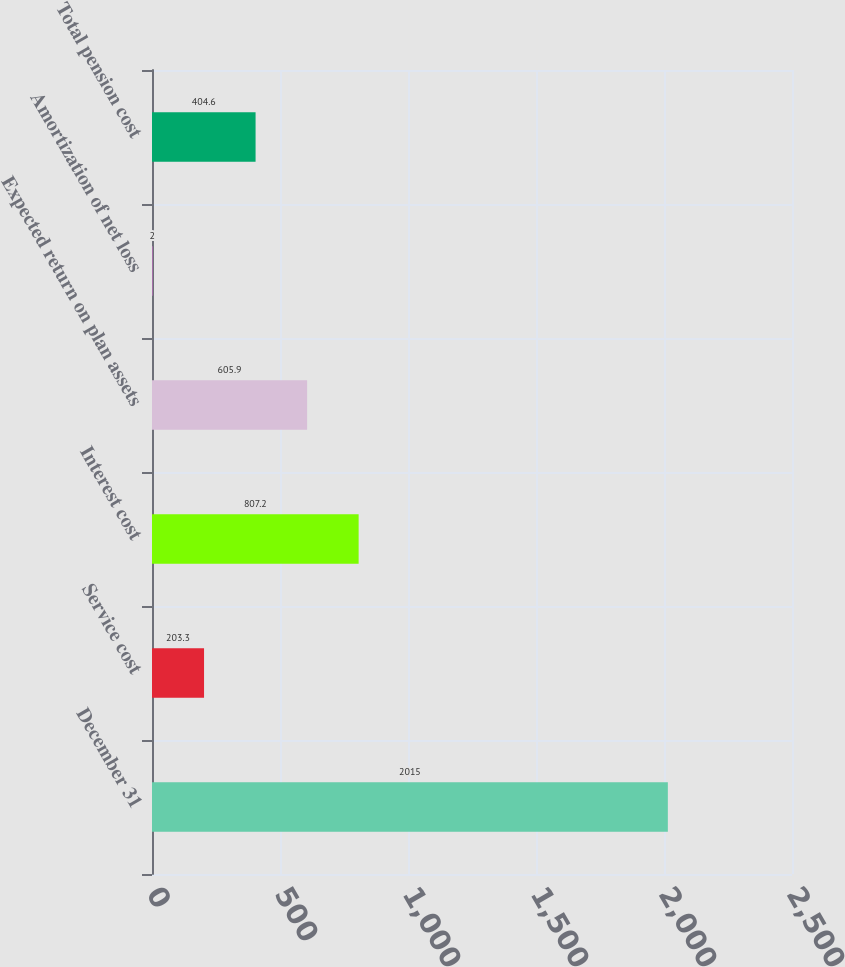<chart> <loc_0><loc_0><loc_500><loc_500><bar_chart><fcel>December 31<fcel>Service cost<fcel>Interest cost<fcel>Expected return on plan assets<fcel>Amortization of net loss<fcel>Total pension cost<nl><fcel>2015<fcel>203.3<fcel>807.2<fcel>605.9<fcel>2<fcel>404.6<nl></chart> 